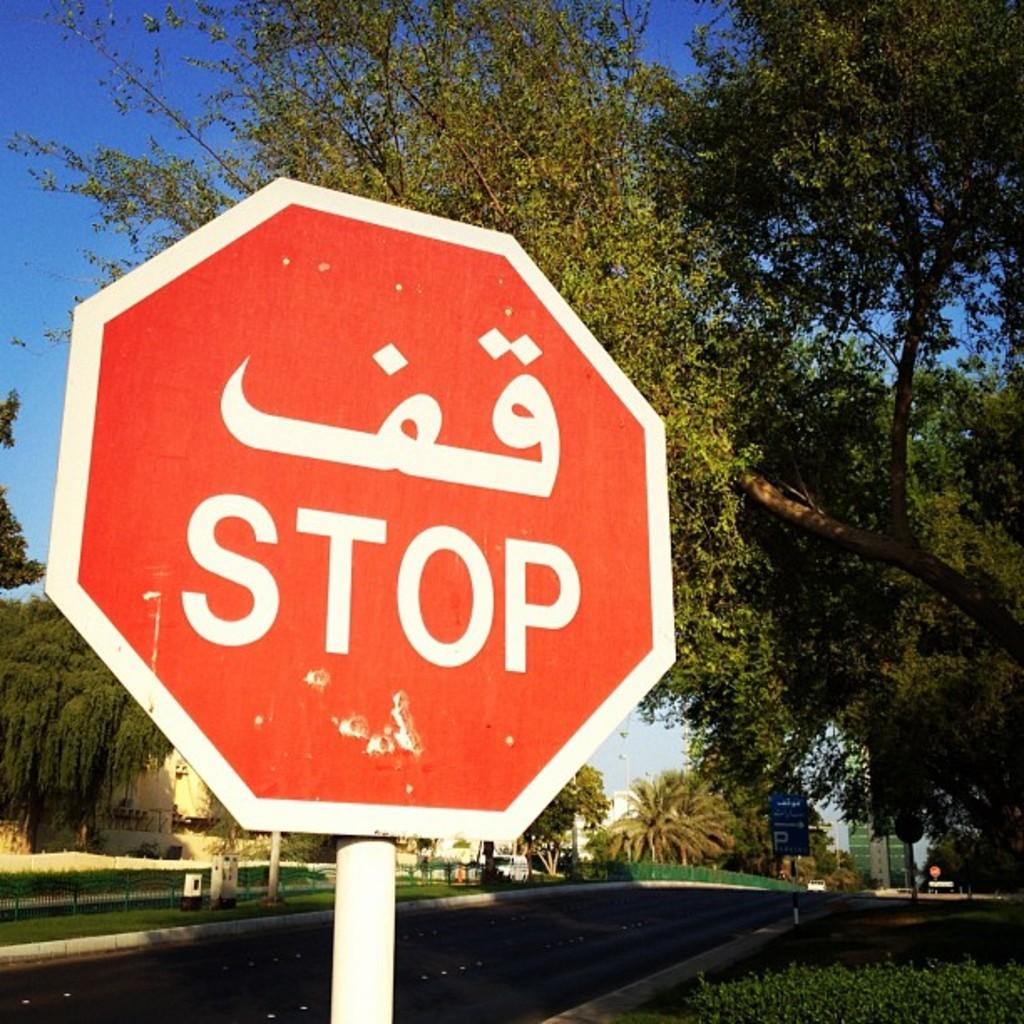Provide a one-sentence caption for the provided image. A red sign says stop in two different languages. 